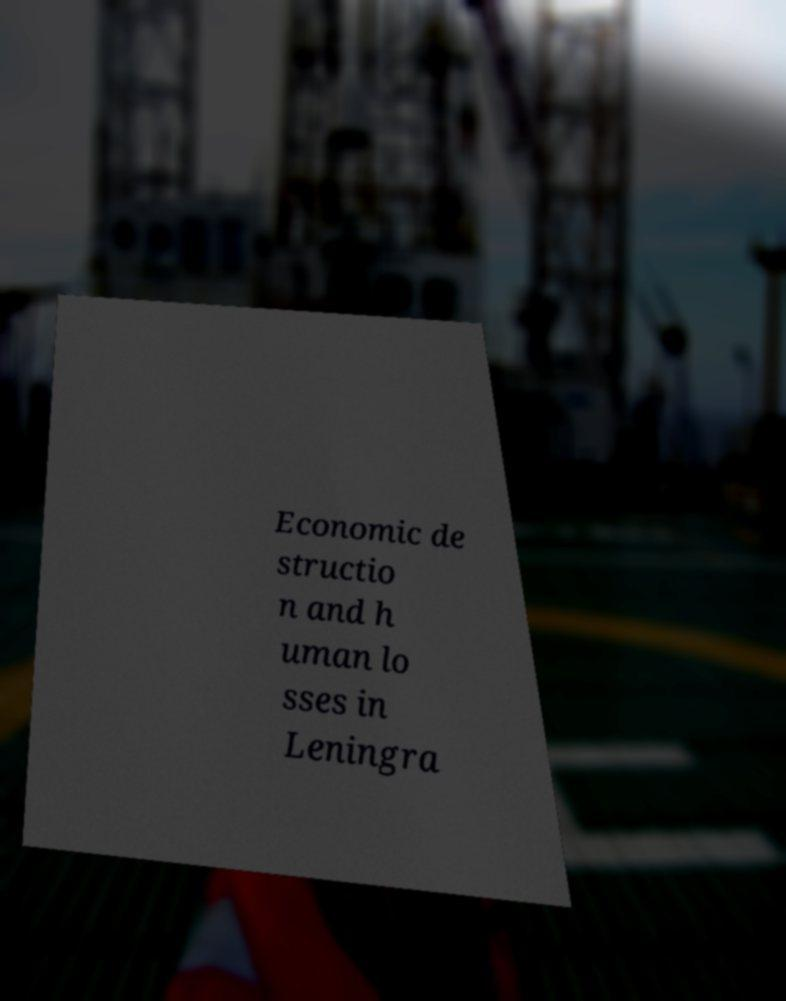Could you assist in decoding the text presented in this image and type it out clearly? Economic de structio n and h uman lo sses in Leningra 